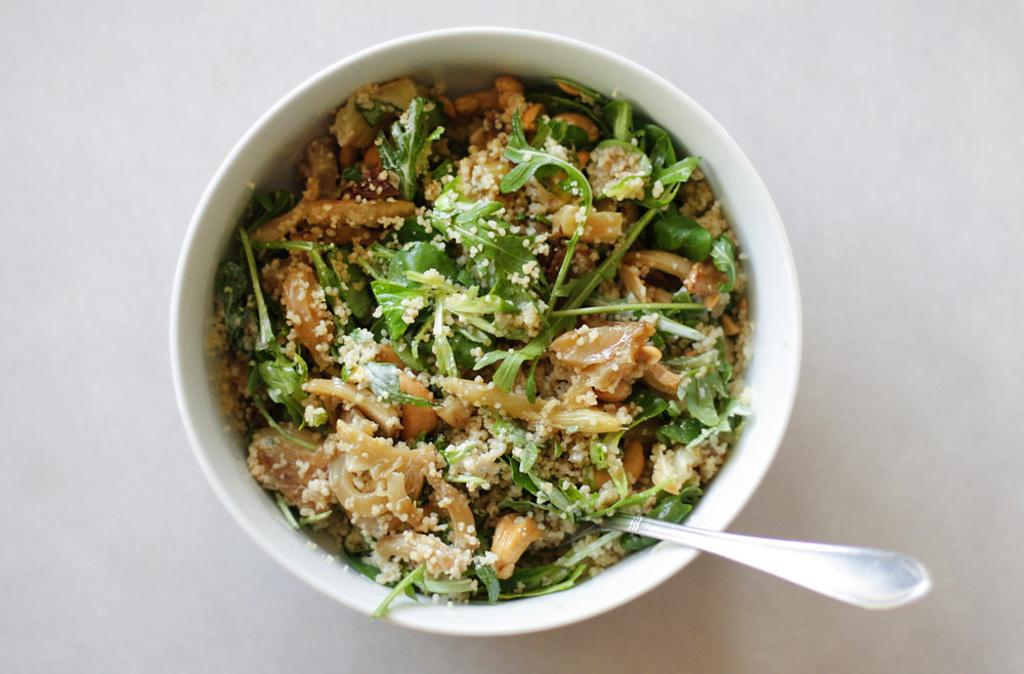What is in the bowl that is visible in the image? There is a bowl with food in the image. What utensil is present in the image? There is a spoon in the image. What type of room is visible in the image? There is no room visible in the image; it only shows a bowl with food and a spoon. 